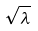<formula> <loc_0><loc_0><loc_500><loc_500>\sqrt { \lambda }</formula> 